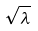<formula> <loc_0><loc_0><loc_500><loc_500>\sqrt { \lambda }</formula> 